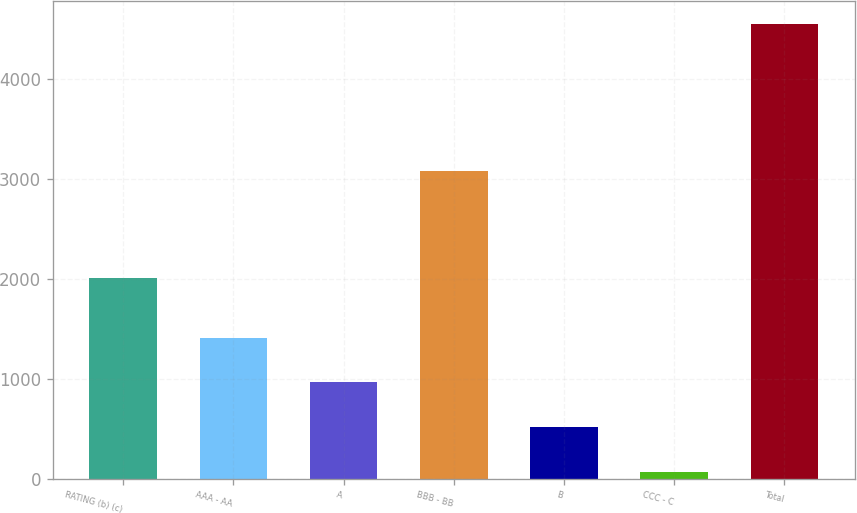Convert chart to OTSL. <chart><loc_0><loc_0><loc_500><loc_500><bar_chart><fcel>RATING (b) (c)<fcel>AAA - AA<fcel>A<fcel>BBB - BB<fcel>B<fcel>CCC - C<fcel>Total<nl><fcel>2013<fcel>1412.2<fcel>963.8<fcel>3080<fcel>515.4<fcel>67<fcel>4551<nl></chart> 